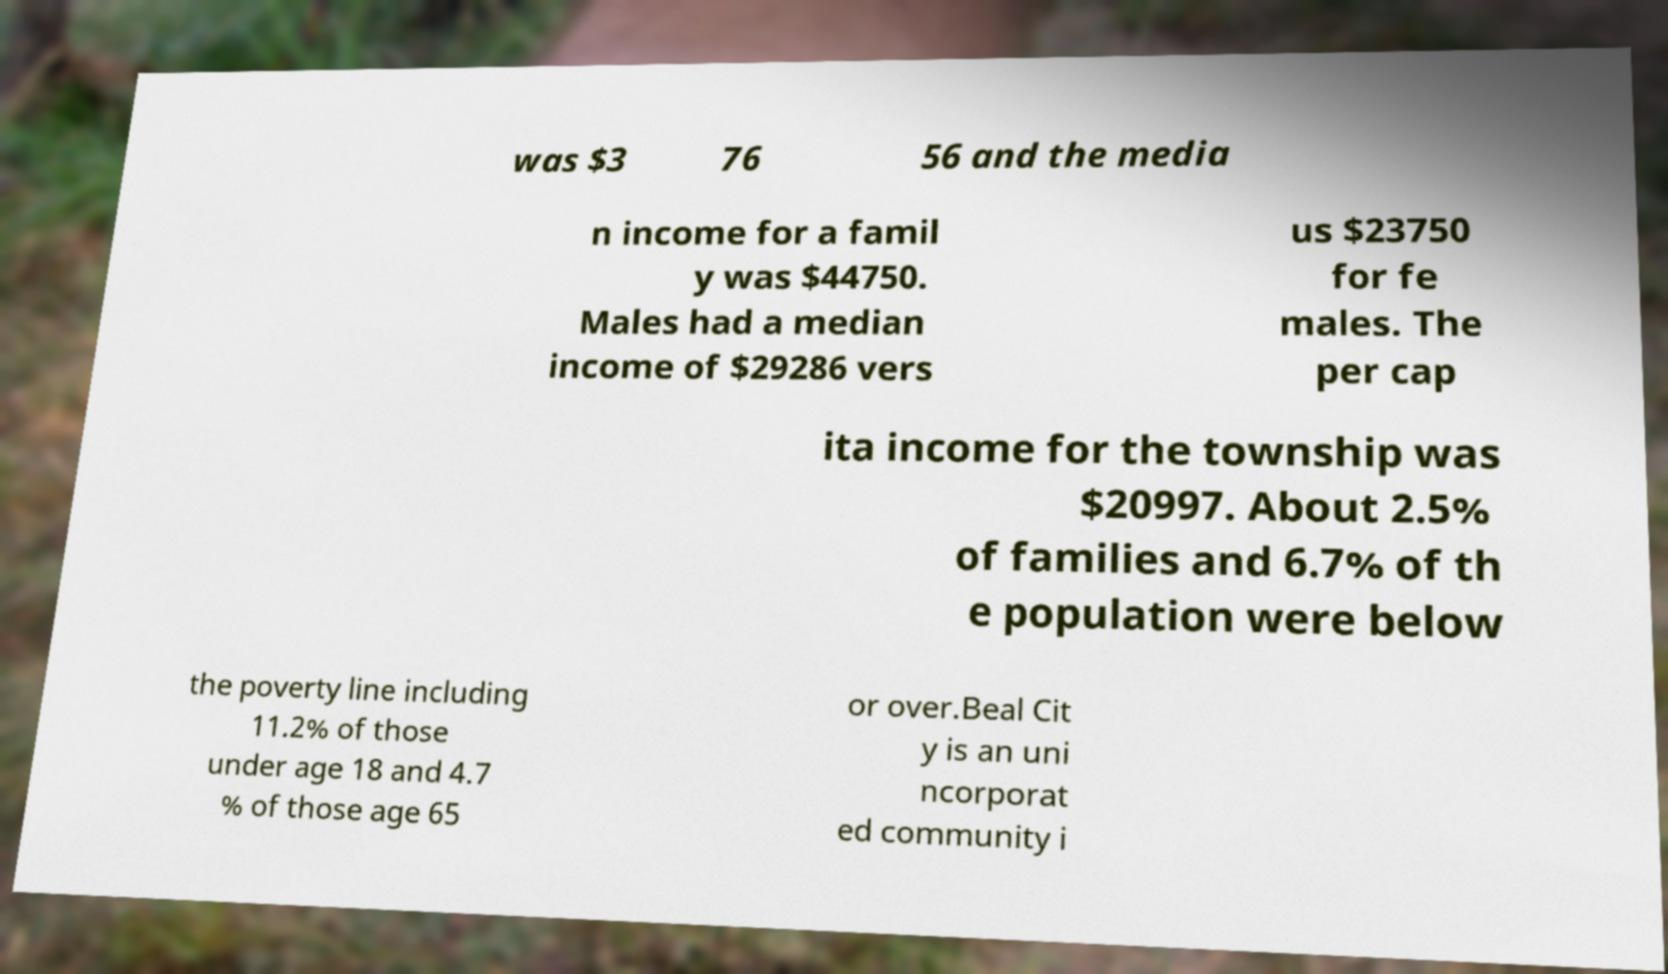Can you accurately transcribe the text from the provided image for me? was $3 76 56 and the media n income for a famil y was $44750. Males had a median income of $29286 vers us $23750 for fe males. The per cap ita income for the township was $20997. About 2.5% of families and 6.7% of th e population were below the poverty line including 11.2% of those under age 18 and 4.7 % of those age 65 or over.Beal Cit y is an uni ncorporat ed community i 